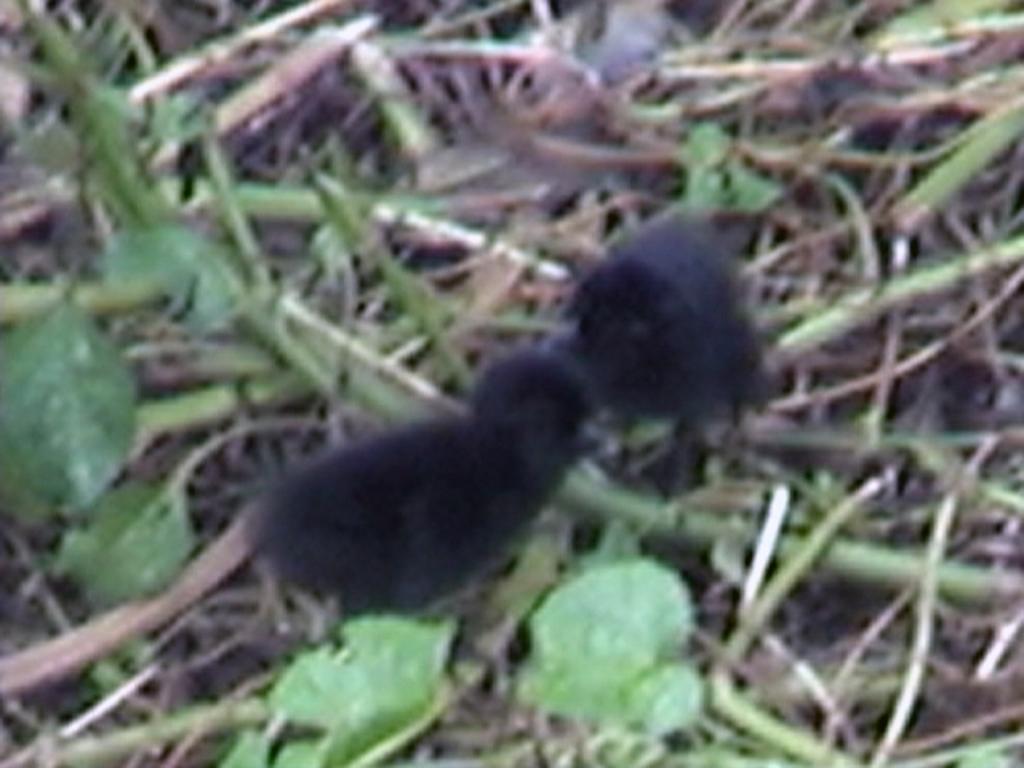How would you summarize this image in a sentence or two? In the center of the image there are birds. At the bottom we can see grass. 